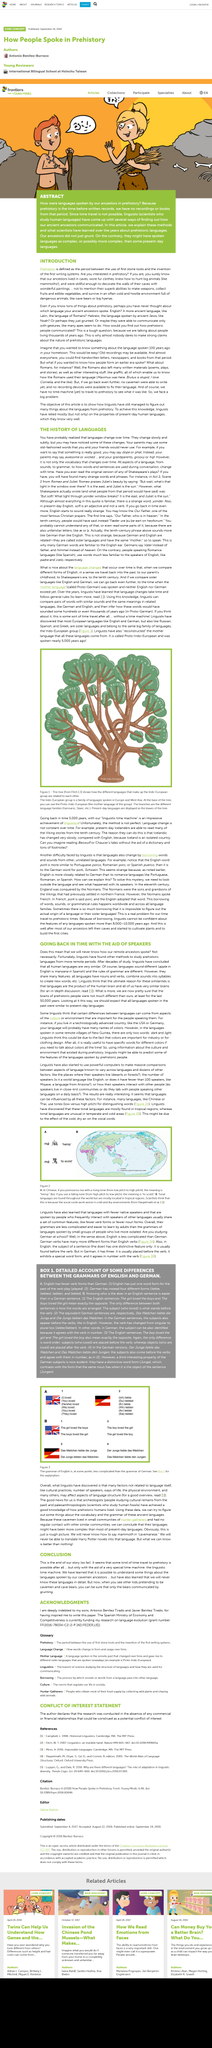Outline some significant characteristics in this image. Prehistory is defined as the period that commenced with the use of the first stone tools and concluded upon the invention of the first writing systems. Hebrew was the language spoken by ancient Jews, including Noah. Proto-Indo-European is the name of the mother language. The Proto-Indo-European mother language was spoken nearly 5,000 years ago. The above picture portrays a representation of the relationship that languages that belong to the Indo-European group share. 